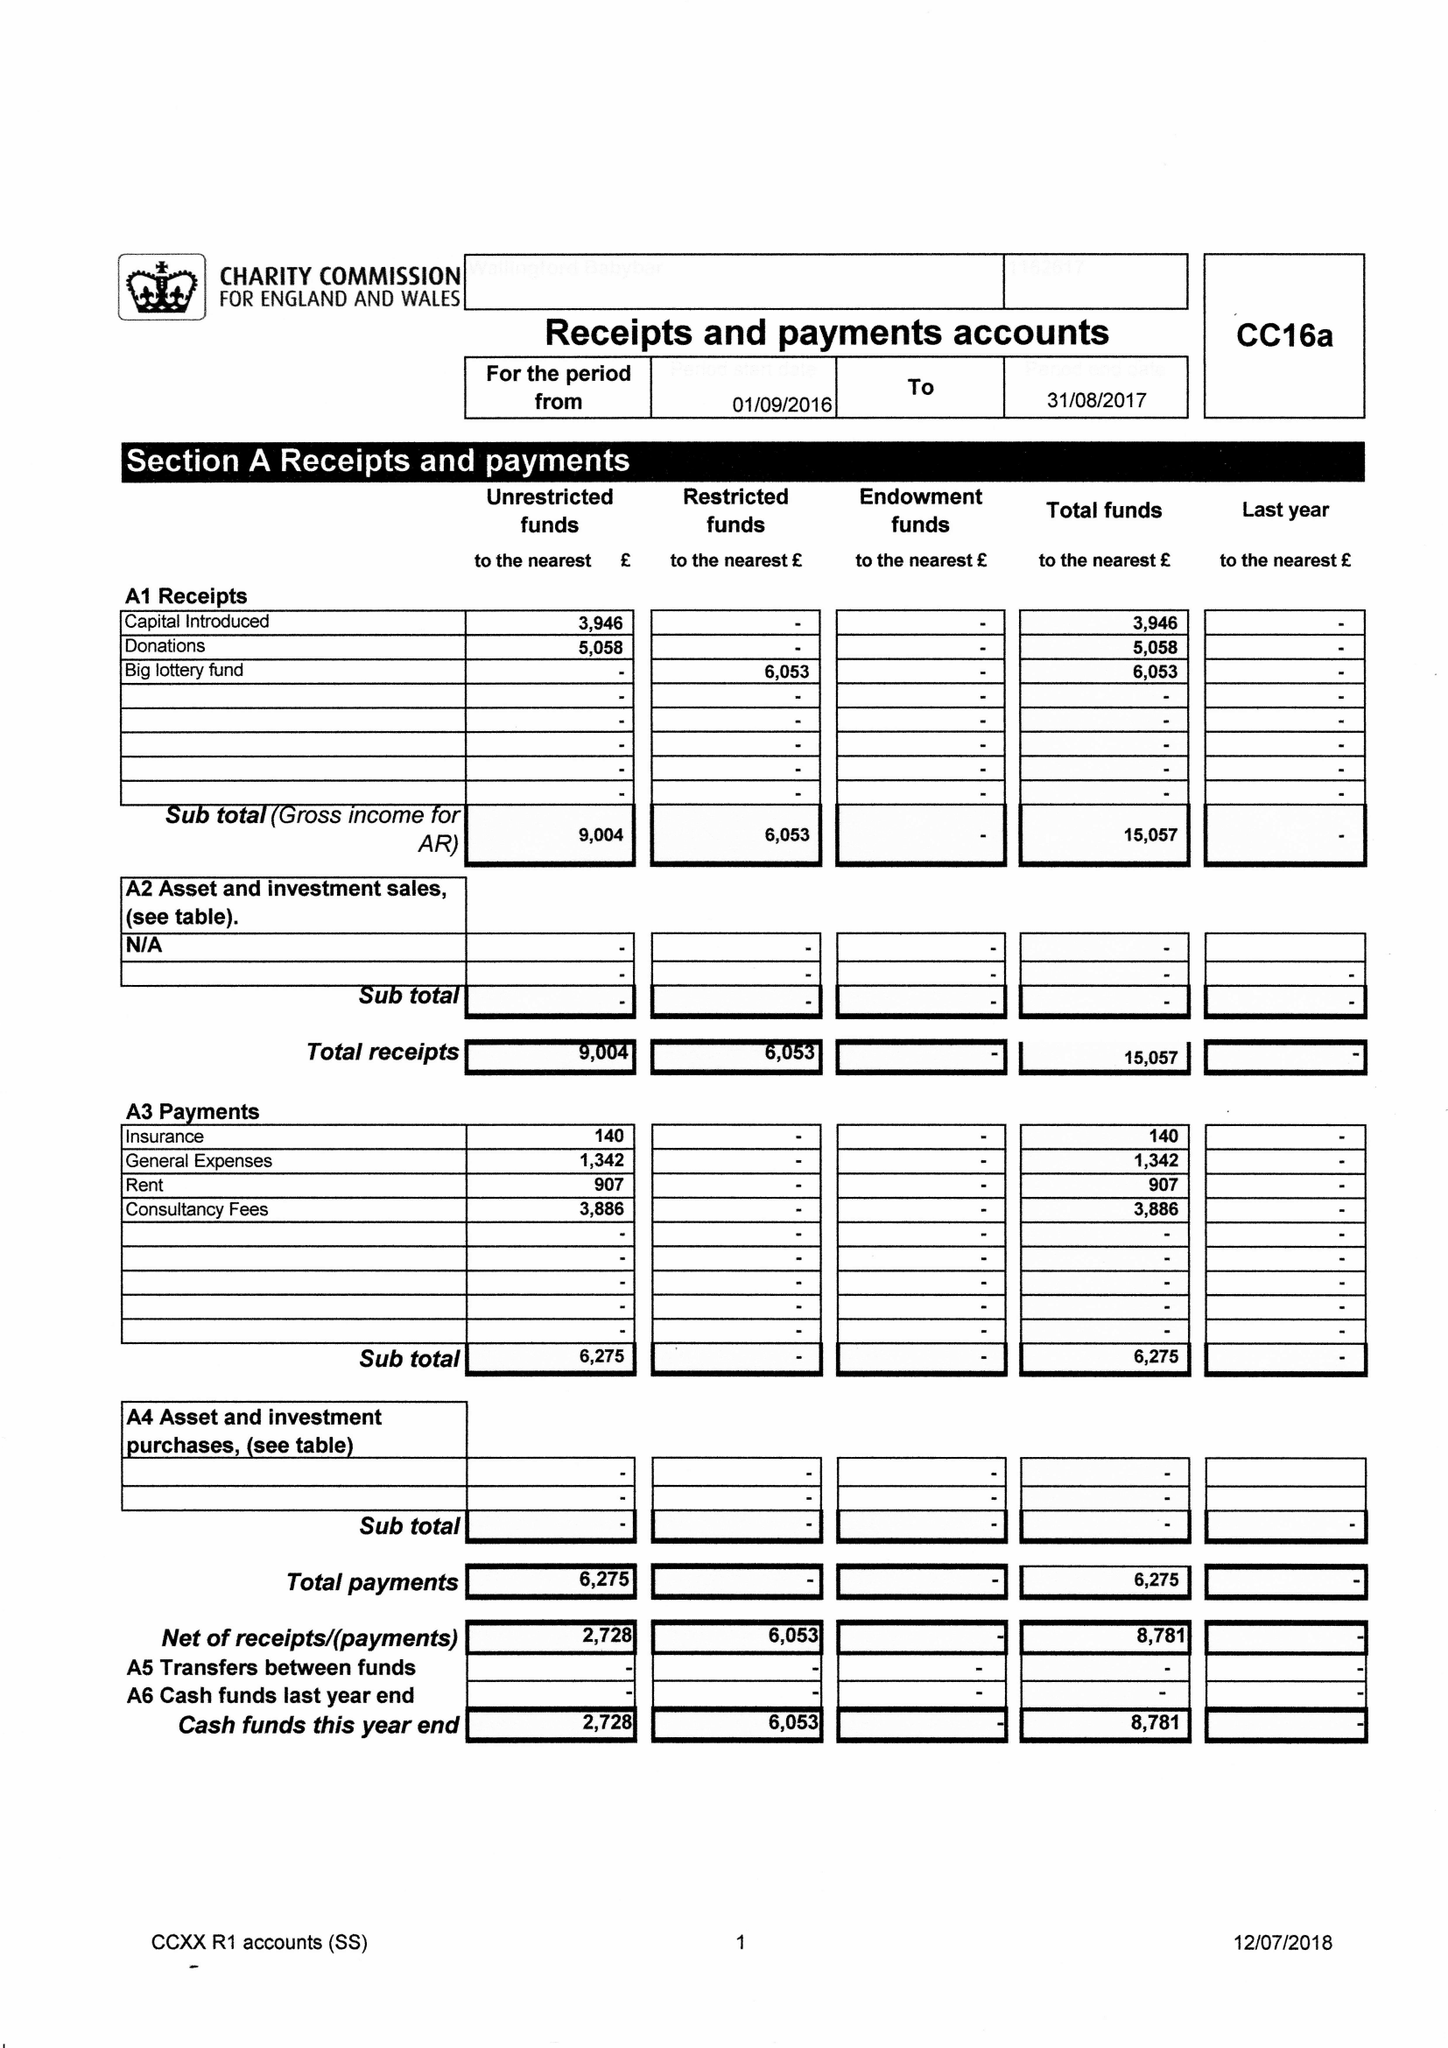What is the value for the report_date?
Answer the question using a single word or phrase. 2017-08-31 